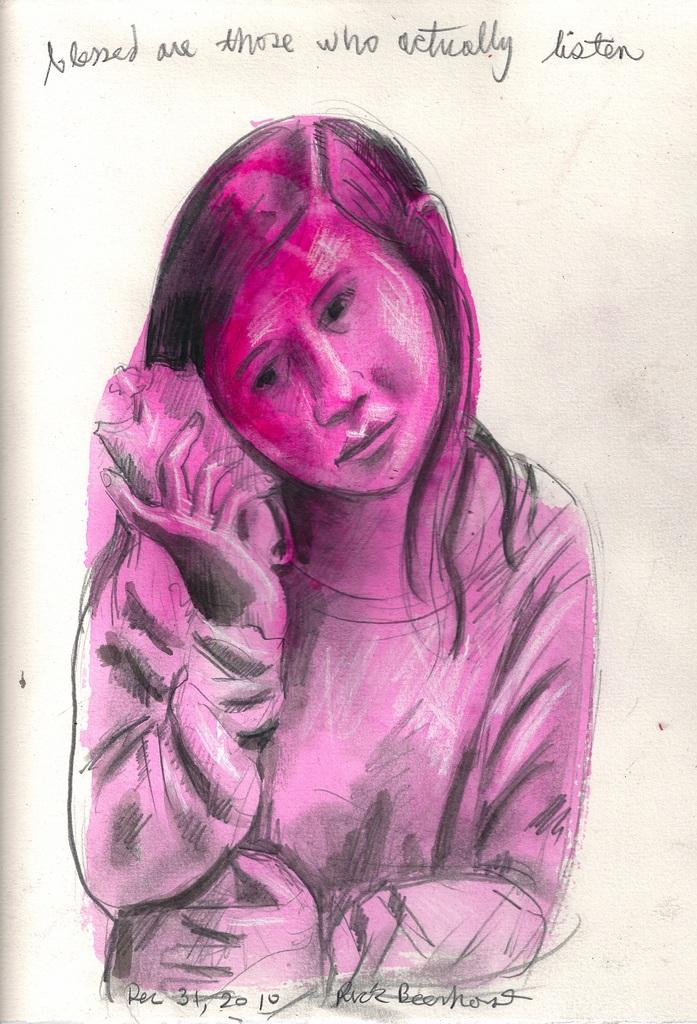What is the main subject of the painting in the image? There is a painting of a girl in the image. What is the girl doing in the painting? The girl is holding something near her ear in the painting. Can you describe any text present in the image? Yes, there is text written on the bottom and top of the image. How many snails can be seen crawling on the girl's hair in the image? There are no snails present in the image; it features a painting of a girl holding something near her ear. 